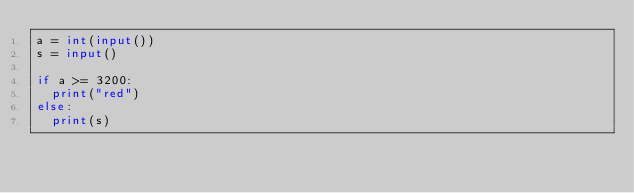<code> <loc_0><loc_0><loc_500><loc_500><_Python_>a = int(input())
s = input()

if a >= 3200:
  print("red")
else:
  print(s)</code> 